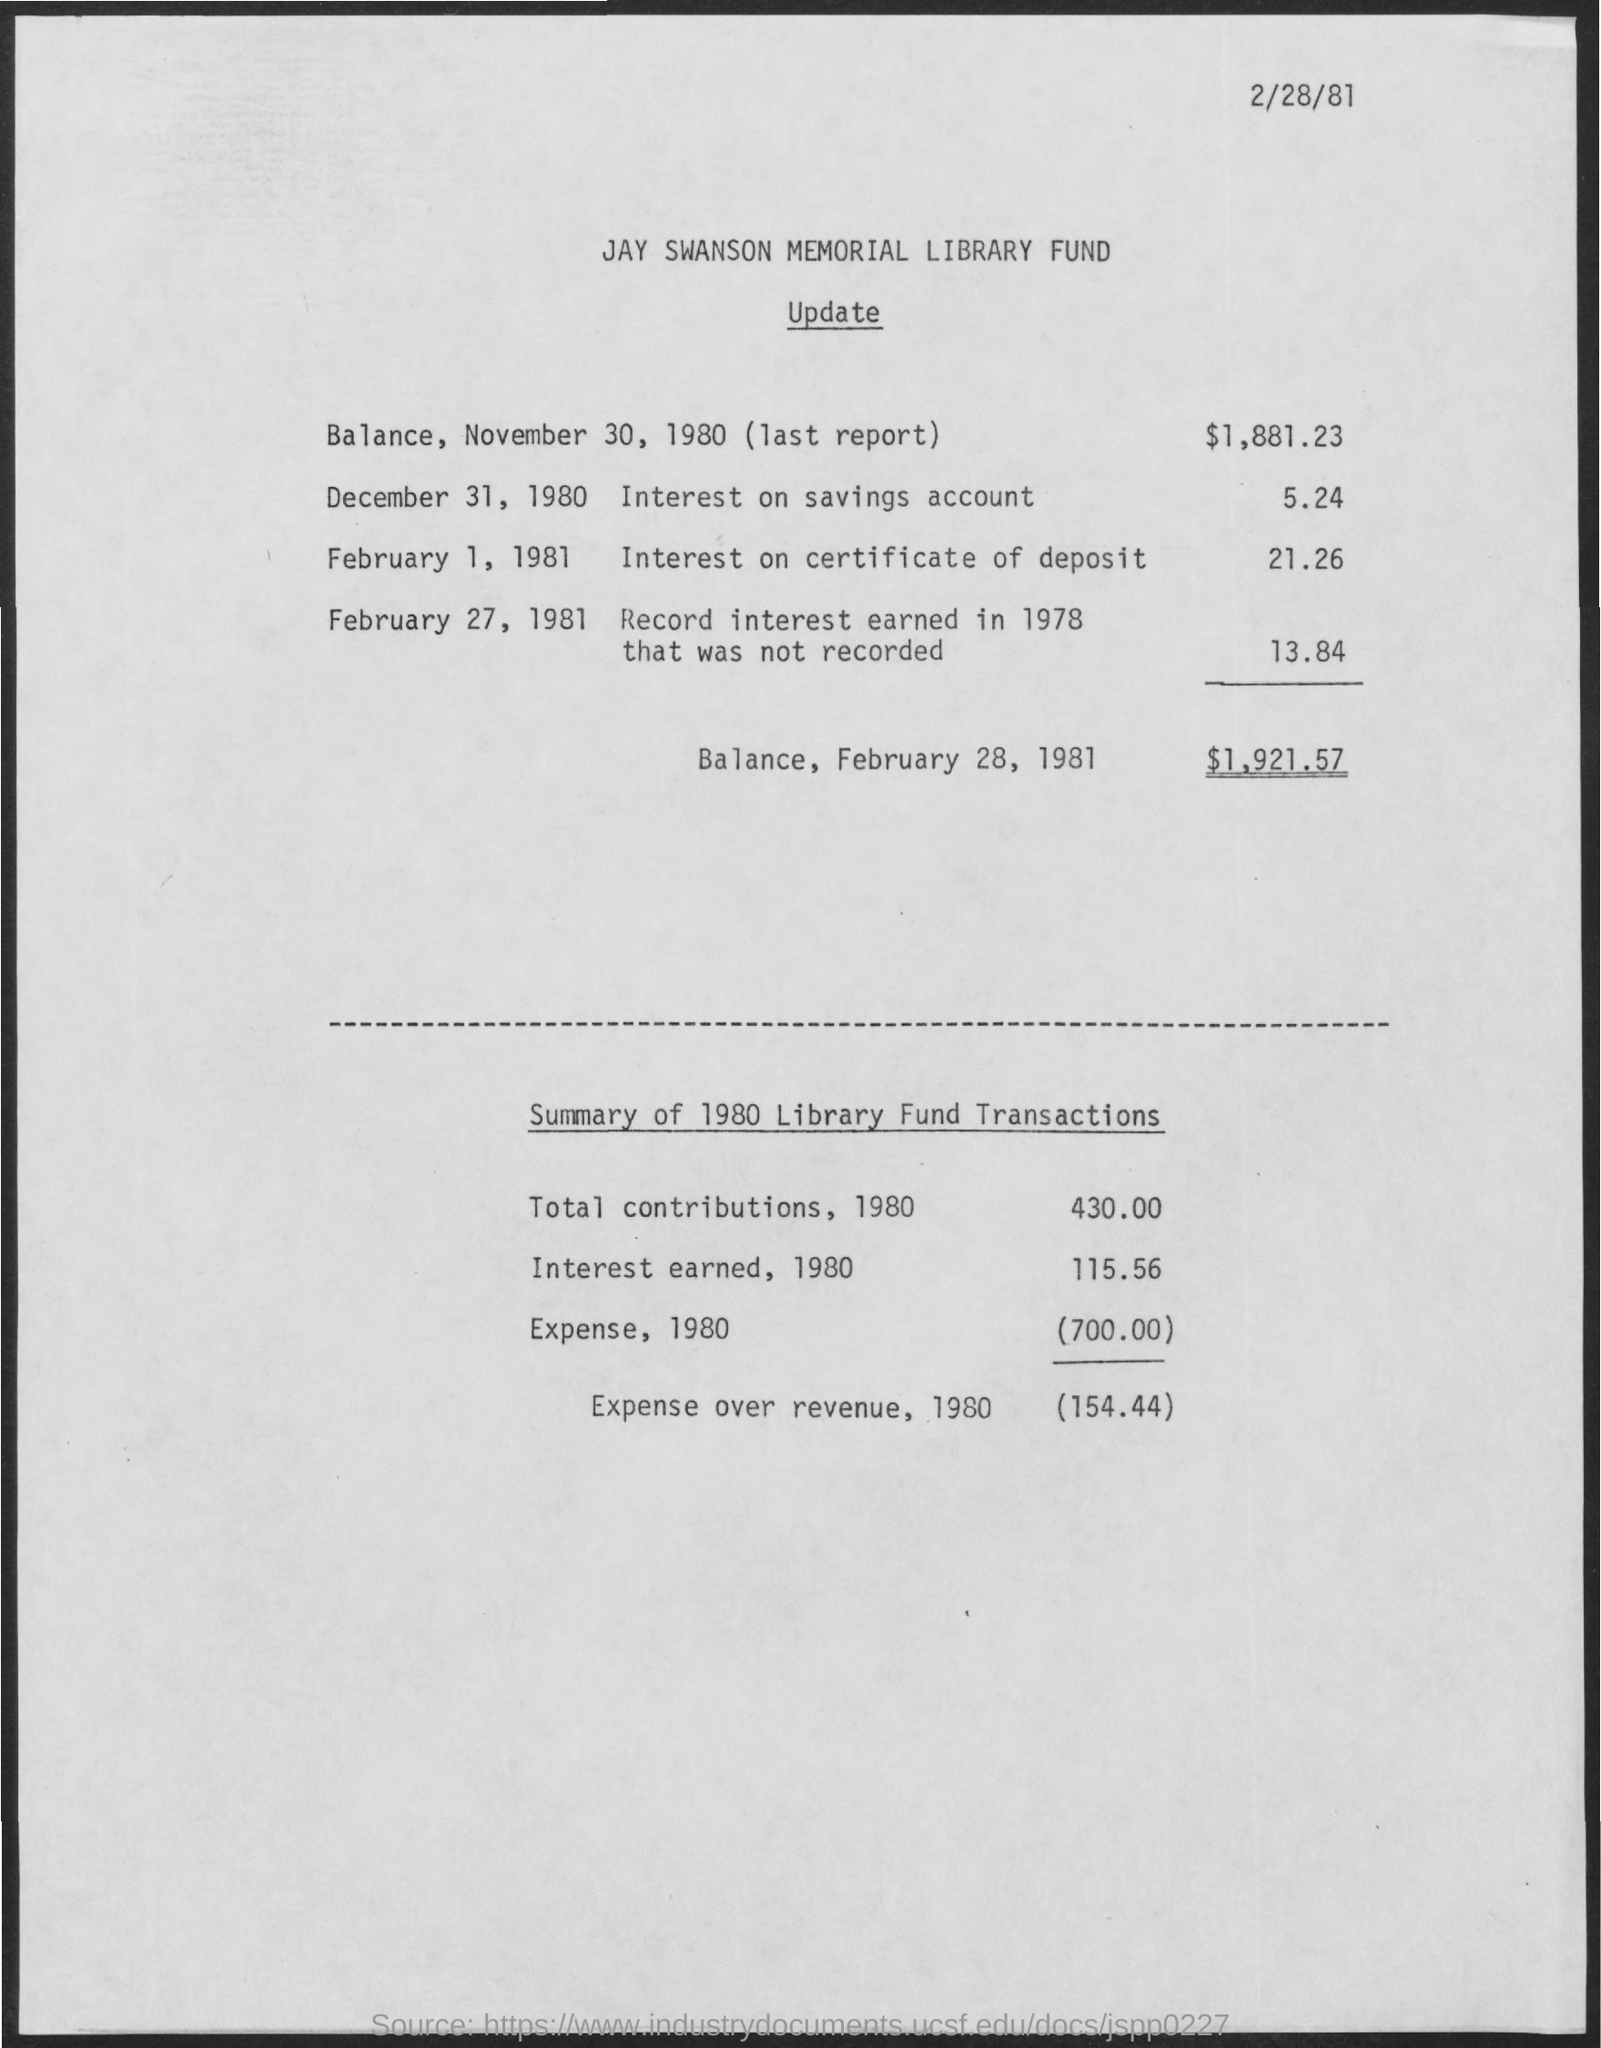What is the first title in the document?
Offer a terse response. Jay Swanson Memorial Library Fund. 